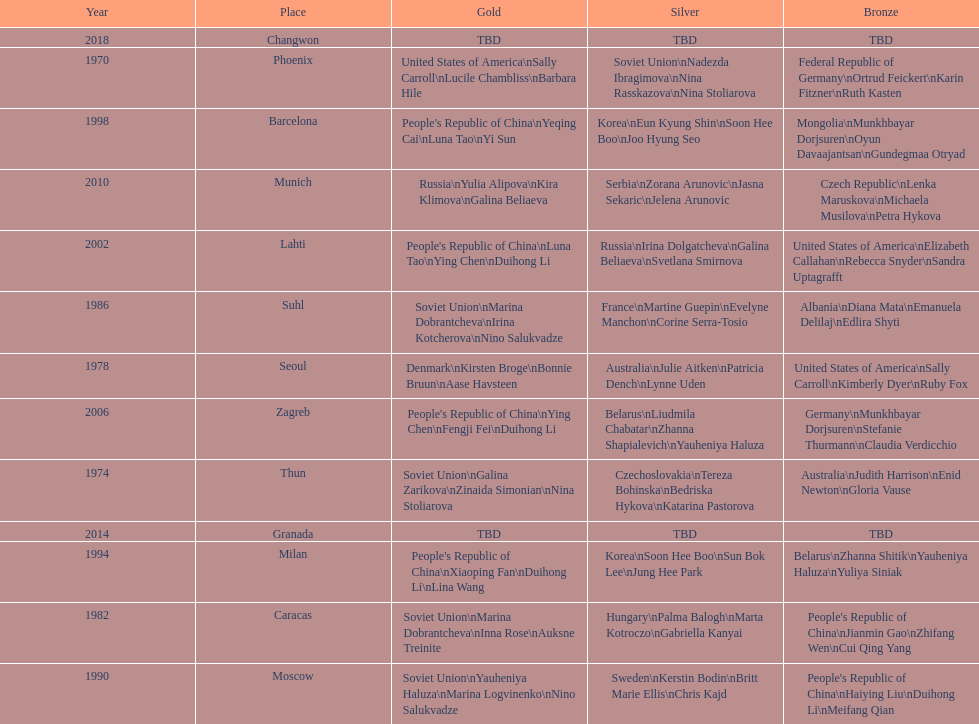How many world championships had the soviet union won first place in in the 25 metre pistol women's world championship? 4. 